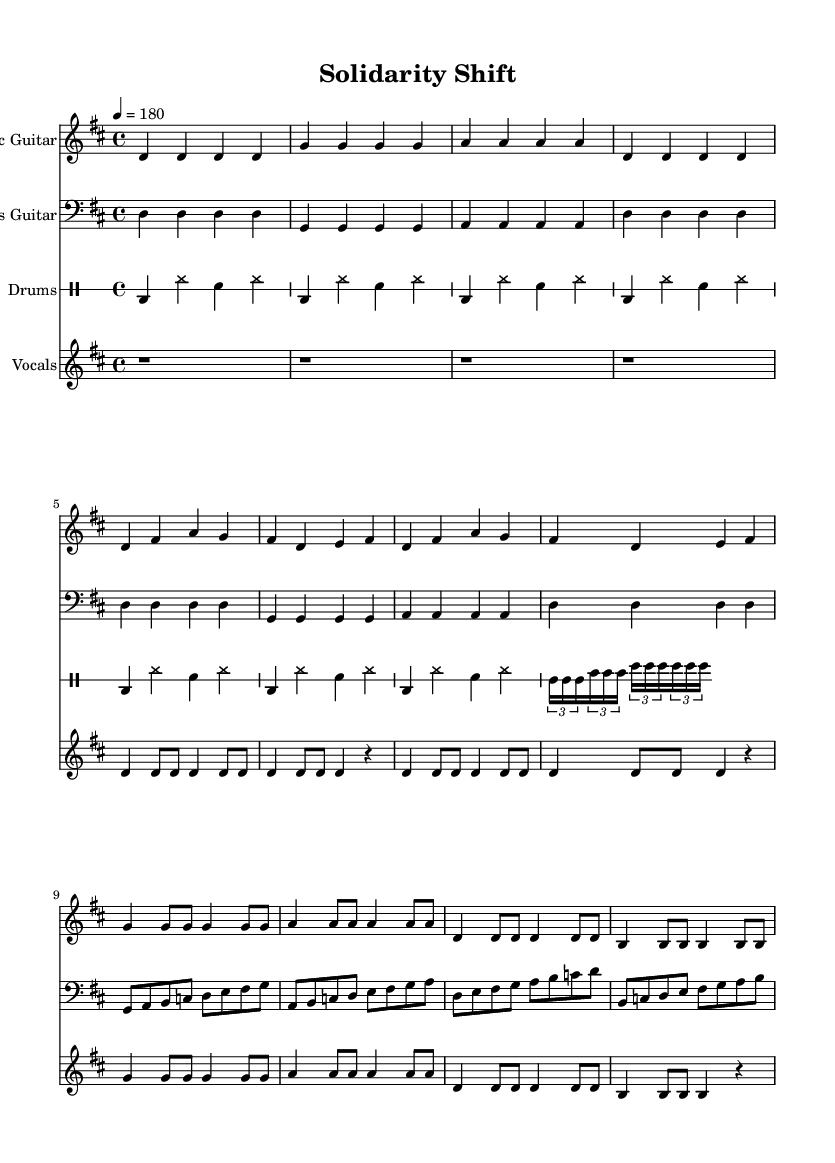What is the key signature of this music? The key signature shows two sharps (F# and C#), indicating the music is in D major. One can determine the key signature by checking the sharp symbols at the beginning of the staff.
Answer: D major What is the time signature of this piece? The time signature is indicated as 4/4, which can be observed at the beginning of the sheet music, specifying four beats per measure.
Answer: 4/4 What is the tempo marking for this song? The tempo indicated is 4 equals 180, suggesting the piece should be played at 180 beats per minute. This marking is found at the beginning of the music above the staff.
Answer: 180 How many measures are there in the chorus section? By counting the measures in the chorus part, we find there are four measures. The chorus is defined by its unique rhythmic and melodic pattern, and it starts after the verse in the music.
Answer: 4 What type of instruments are included in this score? The instruments specified in the score are Electric Guitar, Bass Guitar, Drums, and Vocals. Each instrument's name is listed at the beginning of its respective staff in the sheet music.
Answer: Electric Guitar, Bass Guitar, Drums, Vocals Which section features a drum fill? The part where there is a tuplet filling in the drum part indicates the use of a drum fill. This fill is a distinct rhythmic pattern that adds interest during the transition between sections.
Answer: At the end of the last measure of the verse What kind of musical style does this piece represent? The fast tempo, strong rhythm, and guitar-based instrumentation are characteristics of punk music. Additionally, the thematic focus on camaraderie aligns with typical punk values.
Answer: Punk 